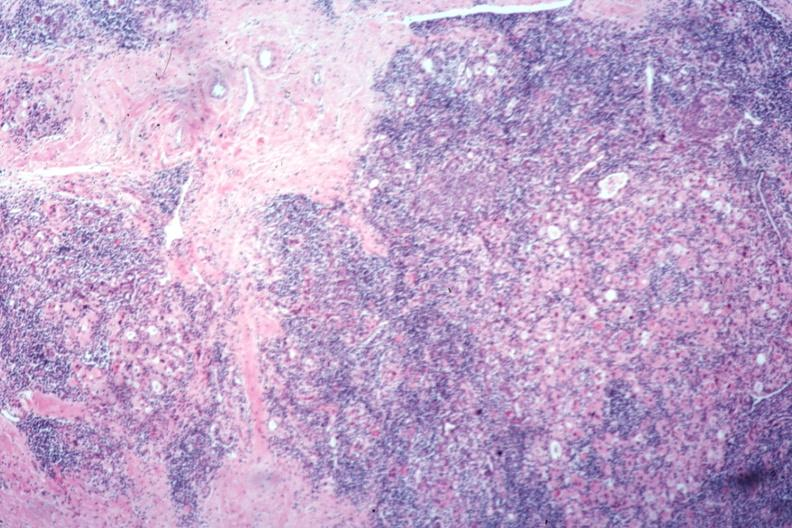what is present?
Answer the question using a single word or phrase. Autoimmune thyroiditis 